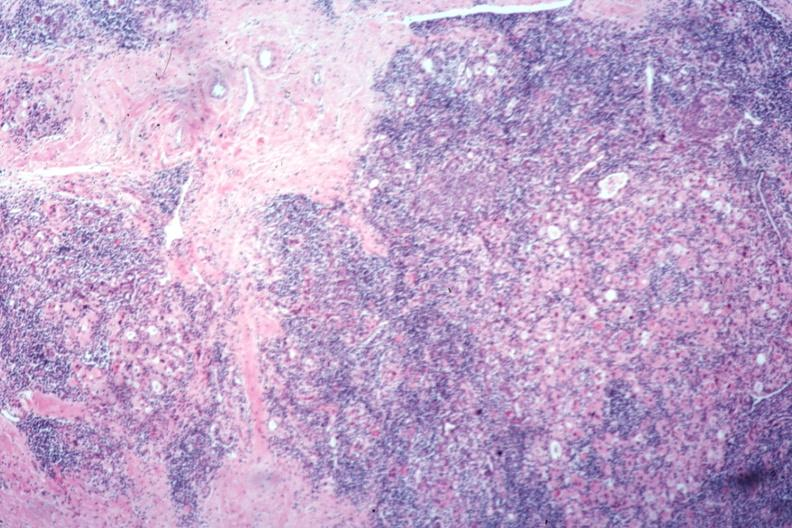what is present?
Answer the question using a single word or phrase. Autoimmune thyroiditis 